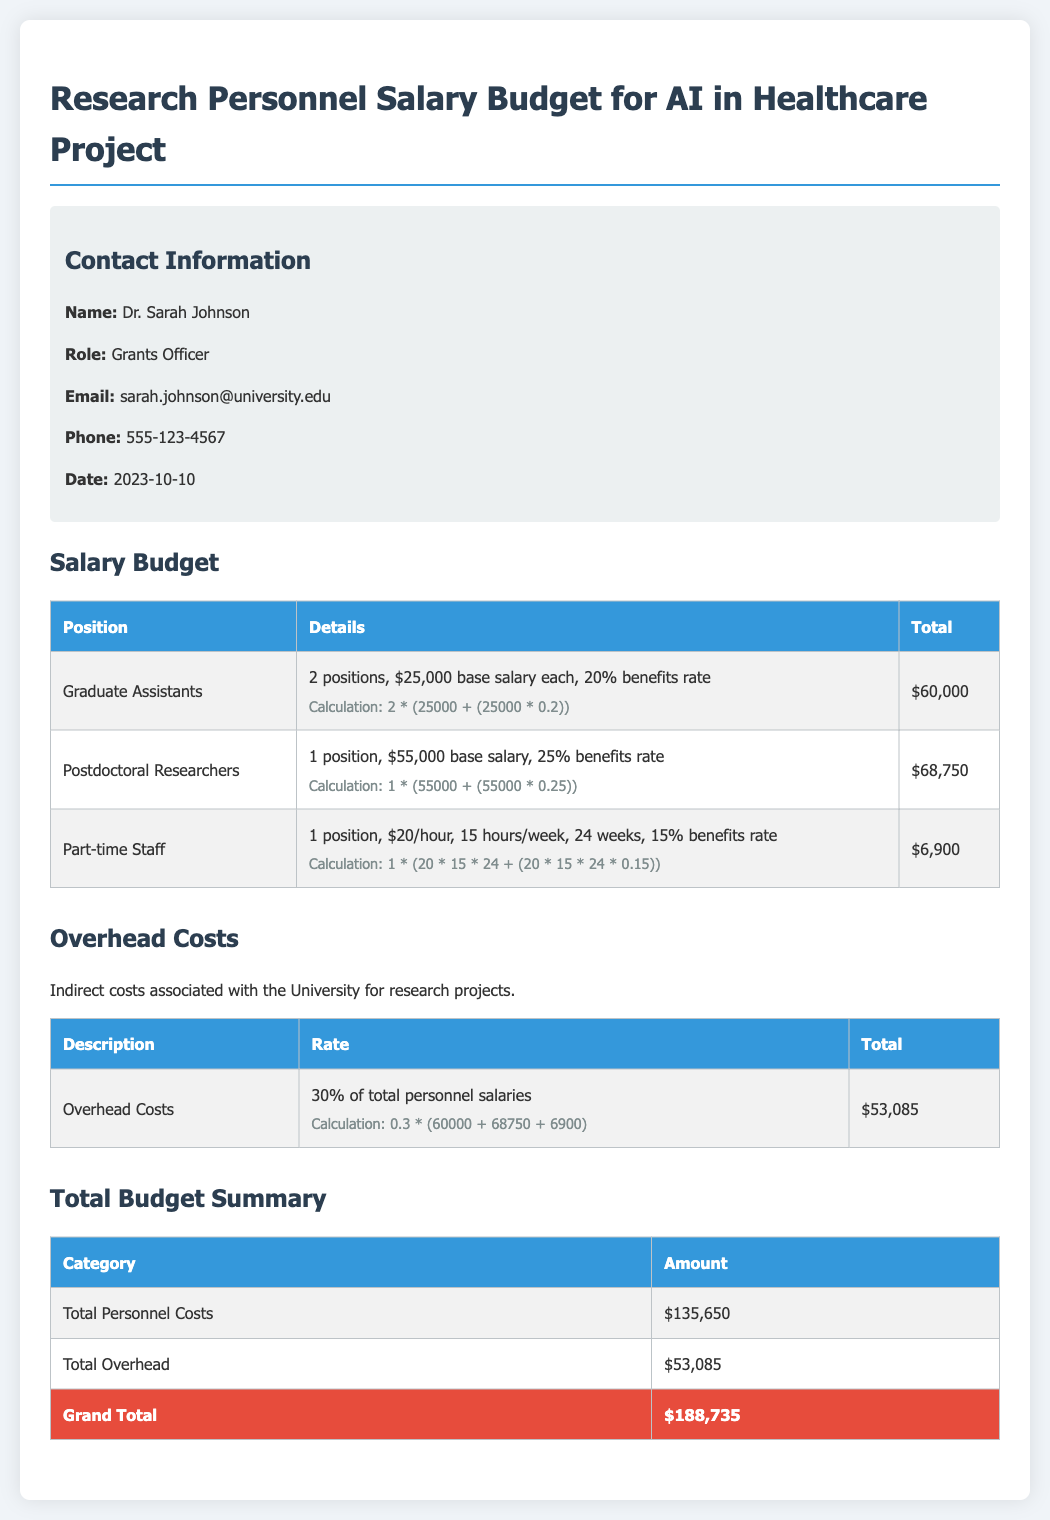What is the total salary budget for graduate assistants? The total salary budget for graduate assistants is calculated as 2 positions at a base salary of $25,000 each with a 20% benefits rate, resulting in $60,000.
Answer: $60,000 What is the base salary for postdoctoral researchers? The base salary for postdoctoral researchers is explicitly stated in the document as $55,000.
Answer: $55,000 How many hours per week does part-time staff work? The document specifies that part-time staff works 15 hours per week, which is mentioned under the part-time staff details.
Answer: 15 hours What is the total amount for overhead costs? The overhead costs are calculated as 30% of the total personnel salaries, which is stated as $53,085 in the overhead costs section.
Answer: $53,085 How many graduate assistants are included in the budget? The number of graduate assistants included in the budget is given in the personnel details section, which notes 2 positions.
Answer: 2 positions What is the total personnel costs? The total personnel costs, which is the sum of all salary components, is stated as $135,650 in the total budget summary.
Answer: $135,650 What is the benefits rate for part-time staff? The benefits rate for part-time staff is mentioned in the document as 15%.
Answer: 15% What is the total grand budget amount? The grand total amount for the budget is presented in the total budget summary as $188,735.
Answer: $188,735 How many positions are included for postdoctoral researchers? The document states that there is 1 position included for postdoctoral researchers.
Answer: 1 position 